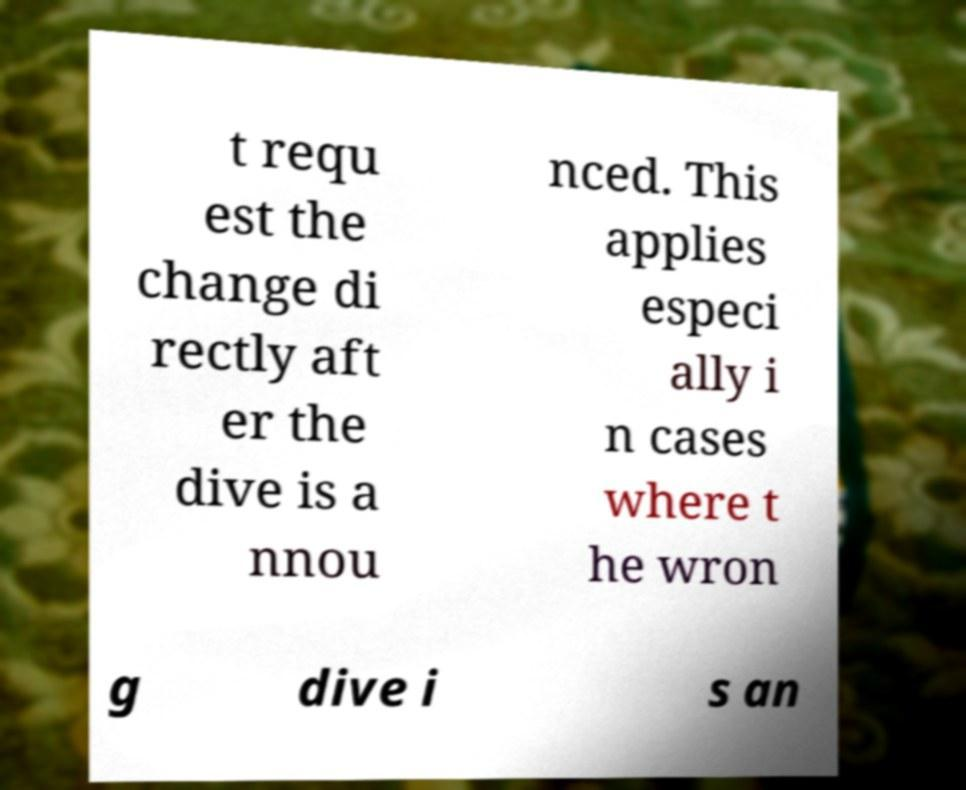I need the written content from this picture converted into text. Can you do that? t requ est the change di rectly aft er the dive is a nnou nced. This applies especi ally i n cases where t he wron g dive i s an 